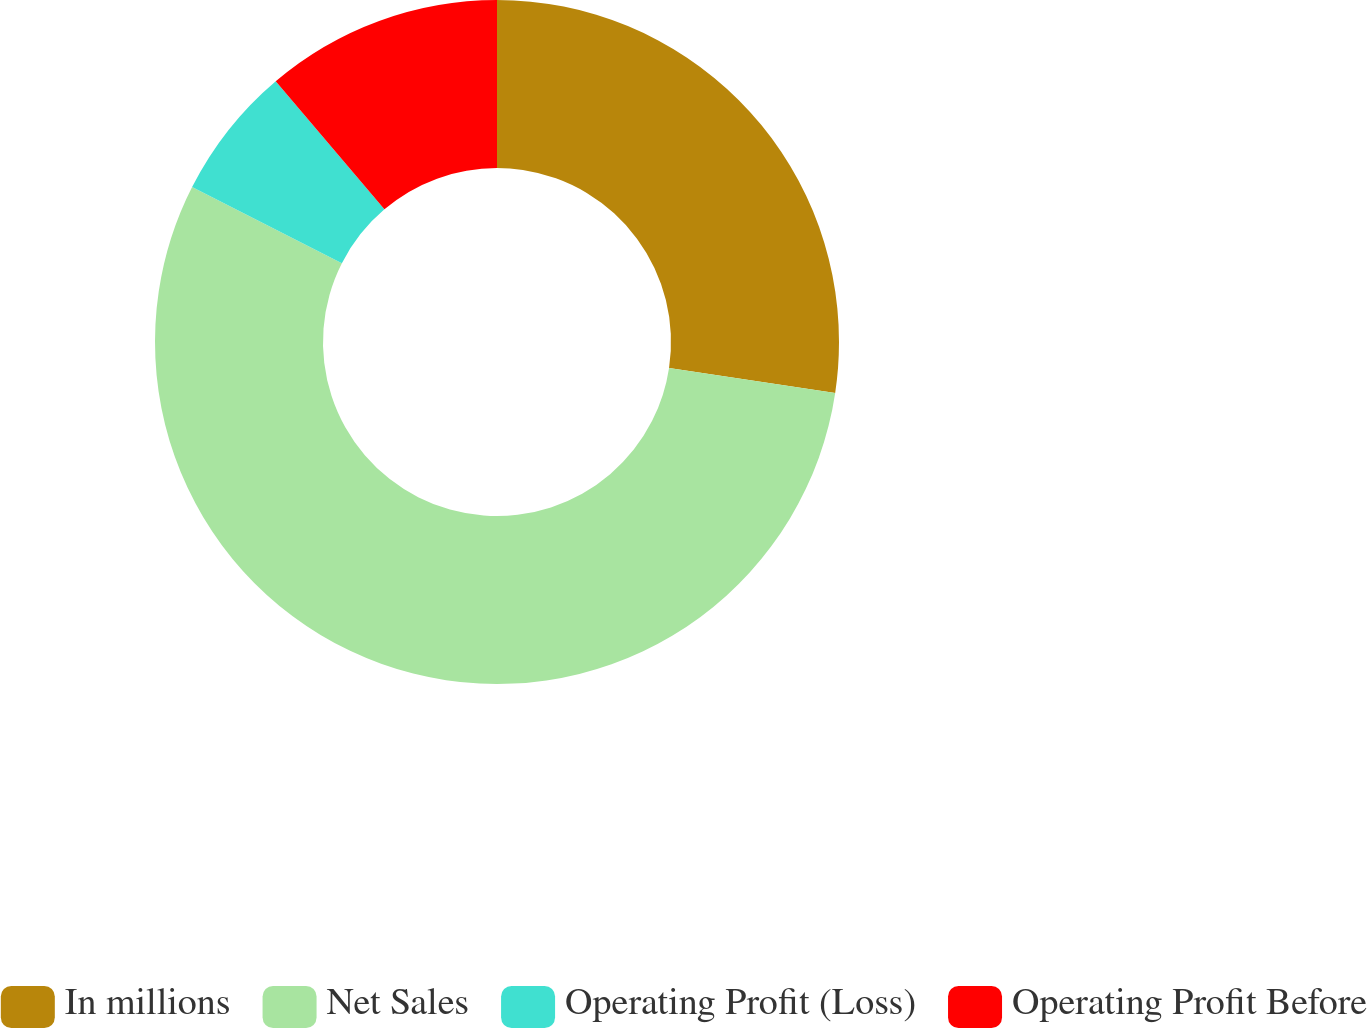Convert chart to OTSL. <chart><loc_0><loc_0><loc_500><loc_500><pie_chart><fcel>In millions<fcel>Net Sales<fcel>Operating Profit (Loss)<fcel>Operating Profit Before<nl><fcel>27.38%<fcel>55.11%<fcel>6.32%<fcel>11.2%<nl></chart> 